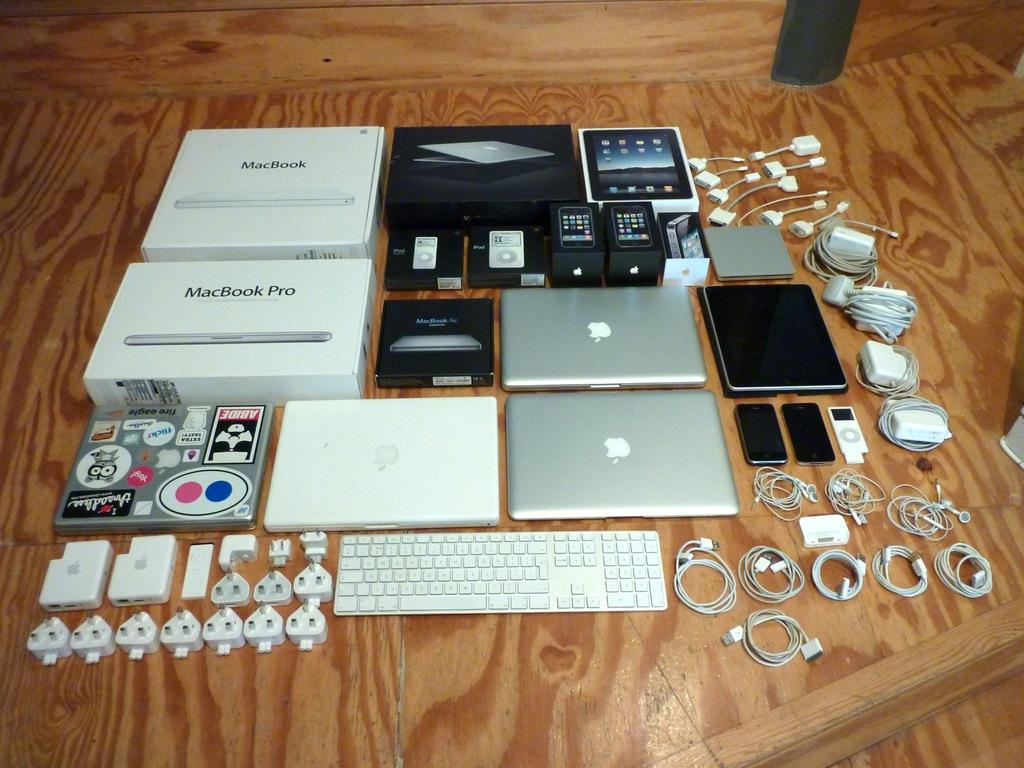<image>
Present a compact description of the photo's key features. Multiple Mac laptops, its accessories, and other Mac products placed on a wooden surface. 